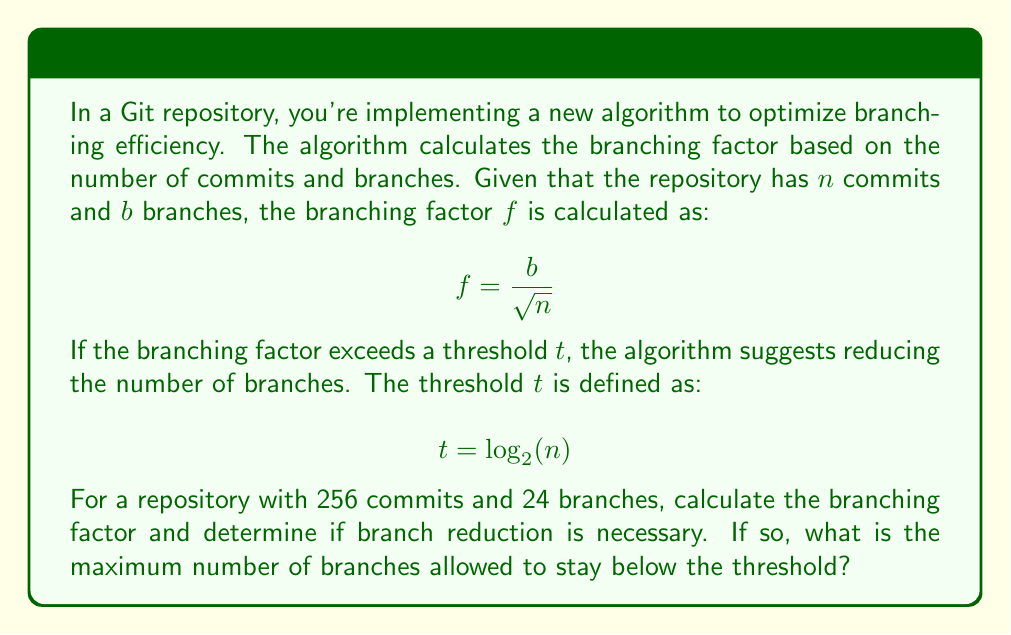Provide a solution to this math problem. Let's approach this problem step by step:

1. Calculate the threshold $t$:
   $$ t = \log_2(n) = \log_2(256) = 8 $$

2. Calculate the current branching factor $f$:
   $$ f = \frac{b}{\sqrt{n}} = \frac{24}{\sqrt{256}} = \frac{24}{16} = 1.5 $$

3. Compare $f$ to $t$:
   Since $1.5 < 8$, branch reduction is not necessary.

4. To find the maximum number of branches allowed:
   We need to solve the equation:
   $$ \frac{b_{max}}{\sqrt{256}} = 8 $$
   
   Rearranging:
   $$ b_{max} = 8 \sqrt{256} = 8 \cdot 16 = 128 $$

Therefore, the maximum number of branches allowed while staying below the threshold is 128.
Answer: The branching factor is 1.5, which is below the threshold of 8. Branch reduction is not necessary. The maximum number of branches allowed while staying below the threshold is 128. 